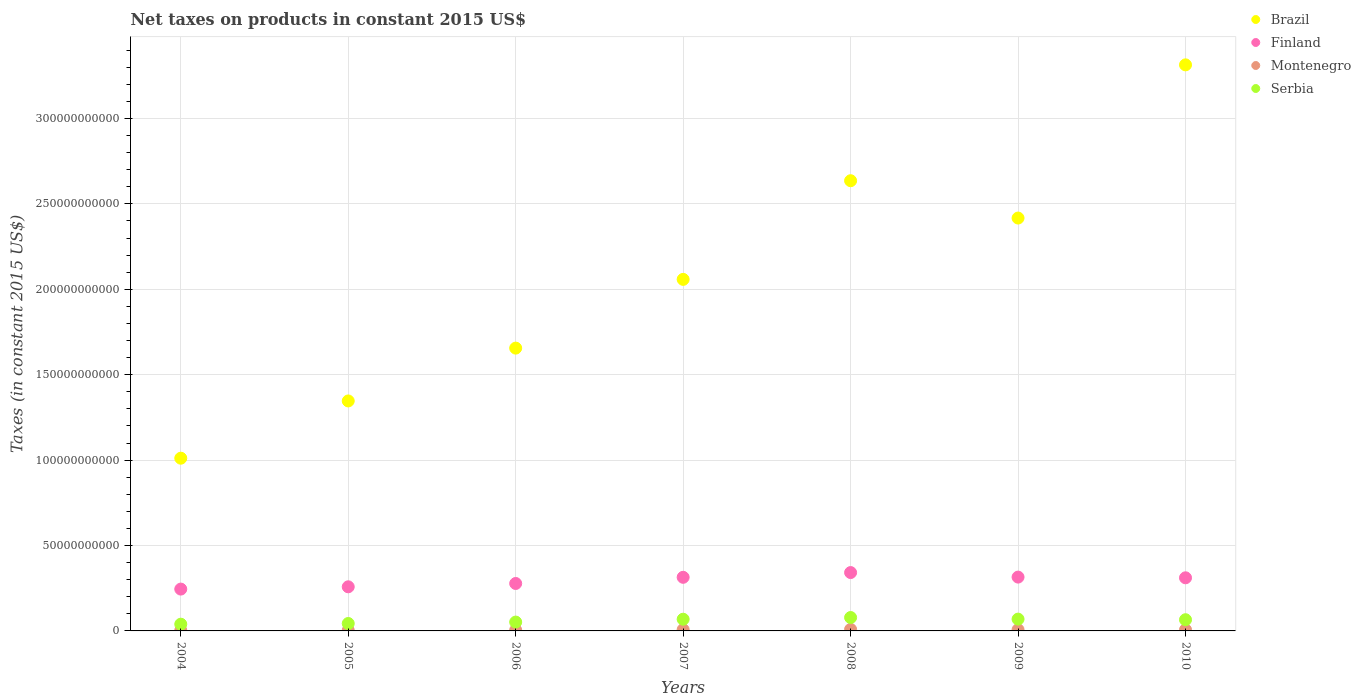What is the net taxes on products in Brazil in 2005?
Make the answer very short. 1.35e+11. Across all years, what is the maximum net taxes on products in Finland?
Your answer should be compact. 3.42e+1. Across all years, what is the minimum net taxes on products in Serbia?
Offer a terse response. 3.94e+09. In which year was the net taxes on products in Serbia maximum?
Provide a succinct answer. 2008. What is the total net taxes on products in Brazil in the graph?
Your answer should be compact. 1.44e+12. What is the difference between the net taxes on products in Serbia in 2004 and that in 2010?
Provide a short and direct response. -2.62e+09. What is the difference between the net taxes on products in Brazil in 2004 and the net taxes on products in Finland in 2008?
Offer a very short reply. 6.70e+1. What is the average net taxes on products in Serbia per year?
Your answer should be compact. 5.95e+09. In the year 2007, what is the difference between the net taxes on products in Serbia and net taxes on products in Montenegro?
Offer a very short reply. 6.09e+09. What is the ratio of the net taxes on products in Brazil in 2005 to that in 2007?
Give a very brief answer. 0.65. Is the difference between the net taxes on products in Serbia in 2005 and 2009 greater than the difference between the net taxes on products in Montenegro in 2005 and 2009?
Offer a very short reply. No. What is the difference between the highest and the second highest net taxes on products in Brazil?
Your answer should be very brief. 6.78e+1. What is the difference between the highest and the lowest net taxes on products in Brazil?
Your response must be concise. 2.30e+11. Is the sum of the net taxes on products in Montenegro in 2005 and 2010 greater than the maximum net taxes on products in Finland across all years?
Make the answer very short. No. Is it the case that in every year, the sum of the net taxes on products in Serbia and net taxes on products in Brazil  is greater than the sum of net taxes on products in Montenegro and net taxes on products in Finland?
Provide a short and direct response. Yes. Is it the case that in every year, the sum of the net taxes on products in Montenegro and net taxes on products in Brazil  is greater than the net taxes on products in Finland?
Give a very brief answer. Yes. Is the net taxes on products in Montenegro strictly greater than the net taxes on products in Brazil over the years?
Your answer should be compact. No. Are the values on the major ticks of Y-axis written in scientific E-notation?
Your answer should be compact. No. Does the graph contain any zero values?
Ensure brevity in your answer.  No. Does the graph contain grids?
Provide a succinct answer. Yes. Where does the legend appear in the graph?
Offer a very short reply. Top right. How are the legend labels stacked?
Your response must be concise. Vertical. What is the title of the graph?
Keep it short and to the point. Net taxes on products in constant 2015 US$. Does "Guatemala" appear as one of the legend labels in the graph?
Keep it short and to the point. No. What is the label or title of the Y-axis?
Keep it short and to the point. Taxes (in constant 2015 US$). What is the Taxes (in constant 2015 US$) of Brazil in 2004?
Your answer should be compact. 1.01e+11. What is the Taxes (in constant 2015 US$) in Finland in 2004?
Your answer should be very brief. 2.45e+1. What is the Taxes (in constant 2015 US$) in Montenegro in 2004?
Provide a short and direct response. 3.08e+08. What is the Taxes (in constant 2015 US$) in Serbia in 2004?
Give a very brief answer. 3.94e+09. What is the Taxes (in constant 2015 US$) of Brazil in 2005?
Offer a very short reply. 1.35e+11. What is the Taxes (in constant 2015 US$) in Finland in 2005?
Give a very brief answer. 2.58e+1. What is the Taxes (in constant 2015 US$) in Montenegro in 2005?
Make the answer very short. 3.67e+08. What is the Taxes (in constant 2015 US$) in Serbia in 2005?
Offer a very short reply. 4.35e+09. What is the Taxes (in constant 2015 US$) in Brazil in 2006?
Keep it short and to the point. 1.66e+11. What is the Taxes (in constant 2015 US$) in Finland in 2006?
Your answer should be very brief. 2.78e+1. What is the Taxes (in constant 2015 US$) in Montenegro in 2006?
Your answer should be compact. 4.97e+08. What is the Taxes (in constant 2015 US$) of Serbia in 2006?
Your answer should be very brief. 5.18e+09. What is the Taxes (in constant 2015 US$) of Brazil in 2007?
Provide a short and direct response. 2.06e+11. What is the Taxes (in constant 2015 US$) in Finland in 2007?
Keep it short and to the point. 3.14e+1. What is the Taxes (in constant 2015 US$) in Montenegro in 2007?
Make the answer very short. 7.52e+08. What is the Taxes (in constant 2015 US$) of Serbia in 2007?
Provide a succinct answer. 6.84e+09. What is the Taxes (in constant 2015 US$) in Brazil in 2008?
Offer a very short reply. 2.64e+11. What is the Taxes (in constant 2015 US$) of Finland in 2008?
Your answer should be compact. 3.42e+1. What is the Taxes (in constant 2015 US$) in Montenegro in 2008?
Keep it short and to the point. 8.92e+08. What is the Taxes (in constant 2015 US$) in Serbia in 2008?
Ensure brevity in your answer.  7.84e+09. What is the Taxes (in constant 2015 US$) of Brazil in 2009?
Keep it short and to the point. 2.42e+11. What is the Taxes (in constant 2015 US$) in Finland in 2009?
Make the answer very short. 3.15e+1. What is the Taxes (in constant 2015 US$) of Montenegro in 2009?
Provide a succinct answer. 7.06e+08. What is the Taxes (in constant 2015 US$) in Serbia in 2009?
Provide a succinct answer. 6.91e+09. What is the Taxes (in constant 2015 US$) of Brazil in 2010?
Offer a terse response. 3.31e+11. What is the Taxes (in constant 2015 US$) in Finland in 2010?
Offer a very short reply. 3.11e+1. What is the Taxes (in constant 2015 US$) of Montenegro in 2010?
Keep it short and to the point. 6.84e+08. What is the Taxes (in constant 2015 US$) in Serbia in 2010?
Make the answer very short. 6.56e+09. Across all years, what is the maximum Taxes (in constant 2015 US$) in Brazil?
Keep it short and to the point. 3.31e+11. Across all years, what is the maximum Taxes (in constant 2015 US$) of Finland?
Offer a very short reply. 3.42e+1. Across all years, what is the maximum Taxes (in constant 2015 US$) in Montenegro?
Ensure brevity in your answer.  8.92e+08. Across all years, what is the maximum Taxes (in constant 2015 US$) in Serbia?
Your answer should be very brief. 7.84e+09. Across all years, what is the minimum Taxes (in constant 2015 US$) of Brazil?
Ensure brevity in your answer.  1.01e+11. Across all years, what is the minimum Taxes (in constant 2015 US$) in Finland?
Give a very brief answer. 2.45e+1. Across all years, what is the minimum Taxes (in constant 2015 US$) in Montenegro?
Your response must be concise. 3.08e+08. Across all years, what is the minimum Taxes (in constant 2015 US$) of Serbia?
Your answer should be very brief. 3.94e+09. What is the total Taxes (in constant 2015 US$) of Brazil in the graph?
Offer a very short reply. 1.44e+12. What is the total Taxes (in constant 2015 US$) in Finland in the graph?
Offer a terse response. 2.06e+11. What is the total Taxes (in constant 2015 US$) of Montenegro in the graph?
Offer a terse response. 4.21e+09. What is the total Taxes (in constant 2015 US$) in Serbia in the graph?
Your answer should be compact. 4.16e+1. What is the difference between the Taxes (in constant 2015 US$) of Brazil in 2004 and that in 2005?
Offer a very short reply. -3.35e+1. What is the difference between the Taxes (in constant 2015 US$) in Finland in 2004 and that in 2005?
Ensure brevity in your answer.  -1.33e+09. What is the difference between the Taxes (in constant 2015 US$) of Montenegro in 2004 and that in 2005?
Provide a short and direct response. -5.85e+07. What is the difference between the Taxes (in constant 2015 US$) in Serbia in 2004 and that in 2005?
Your answer should be very brief. -4.05e+08. What is the difference between the Taxes (in constant 2015 US$) in Brazil in 2004 and that in 2006?
Your answer should be compact. -6.45e+1. What is the difference between the Taxes (in constant 2015 US$) of Finland in 2004 and that in 2006?
Provide a succinct answer. -3.28e+09. What is the difference between the Taxes (in constant 2015 US$) in Montenegro in 2004 and that in 2006?
Offer a very short reply. -1.89e+08. What is the difference between the Taxes (in constant 2015 US$) of Serbia in 2004 and that in 2006?
Your answer should be very brief. -1.24e+09. What is the difference between the Taxes (in constant 2015 US$) of Brazil in 2004 and that in 2007?
Your answer should be very brief. -1.05e+11. What is the difference between the Taxes (in constant 2015 US$) in Finland in 2004 and that in 2007?
Ensure brevity in your answer.  -6.89e+09. What is the difference between the Taxes (in constant 2015 US$) of Montenegro in 2004 and that in 2007?
Keep it short and to the point. -4.43e+08. What is the difference between the Taxes (in constant 2015 US$) of Serbia in 2004 and that in 2007?
Your answer should be compact. -2.90e+09. What is the difference between the Taxes (in constant 2015 US$) of Brazil in 2004 and that in 2008?
Ensure brevity in your answer.  -1.62e+11. What is the difference between the Taxes (in constant 2015 US$) of Finland in 2004 and that in 2008?
Give a very brief answer. -9.67e+09. What is the difference between the Taxes (in constant 2015 US$) of Montenegro in 2004 and that in 2008?
Make the answer very short. -5.84e+08. What is the difference between the Taxes (in constant 2015 US$) in Serbia in 2004 and that in 2008?
Offer a terse response. -3.90e+09. What is the difference between the Taxes (in constant 2015 US$) in Brazil in 2004 and that in 2009?
Keep it short and to the point. -1.41e+11. What is the difference between the Taxes (in constant 2015 US$) in Finland in 2004 and that in 2009?
Provide a succinct answer. -7.02e+09. What is the difference between the Taxes (in constant 2015 US$) of Montenegro in 2004 and that in 2009?
Provide a succinct answer. -3.98e+08. What is the difference between the Taxes (in constant 2015 US$) of Serbia in 2004 and that in 2009?
Give a very brief answer. -2.97e+09. What is the difference between the Taxes (in constant 2015 US$) in Brazil in 2004 and that in 2010?
Offer a terse response. -2.30e+11. What is the difference between the Taxes (in constant 2015 US$) of Finland in 2004 and that in 2010?
Make the answer very short. -6.61e+09. What is the difference between the Taxes (in constant 2015 US$) of Montenegro in 2004 and that in 2010?
Your answer should be compact. -3.76e+08. What is the difference between the Taxes (in constant 2015 US$) of Serbia in 2004 and that in 2010?
Keep it short and to the point. -2.62e+09. What is the difference between the Taxes (in constant 2015 US$) of Brazil in 2005 and that in 2006?
Offer a very short reply. -3.09e+1. What is the difference between the Taxes (in constant 2015 US$) of Finland in 2005 and that in 2006?
Make the answer very short. -1.95e+09. What is the difference between the Taxes (in constant 2015 US$) of Montenegro in 2005 and that in 2006?
Your answer should be compact. -1.30e+08. What is the difference between the Taxes (in constant 2015 US$) in Serbia in 2005 and that in 2006?
Make the answer very short. -8.37e+08. What is the difference between the Taxes (in constant 2015 US$) in Brazil in 2005 and that in 2007?
Your answer should be compact. -7.12e+1. What is the difference between the Taxes (in constant 2015 US$) in Finland in 2005 and that in 2007?
Your answer should be very brief. -5.56e+09. What is the difference between the Taxes (in constant 2015 US$) in Montenegro in 2005 and that in 2007?
Keep it short and to the point. -3.85e+08. What is the difference between the Taxes (in constant 2015 US$) of Serbia in 2005 and that in 2007?
Your response must be concise. -2.50e+09. What is the difference between the Taxes (in constant 2015 US$) in Brazil in 2005 and that in 2008?
Your response must be concise. -1.29e+11. What is the difference between the Taxes (in constant 2015 US$) in Finland in 2005 and that in 2008?
Make the answer very short. -8.34e+09. What is the difference between the Taxes (in constant 2015 US$) of Montenegro in 2005 and that in 2008?
Make the answer very short. -5.25e+08. What is the difference between the Taxes (in constant 2015 US$) of Serbia in 2005 and that in 2008?
Ensure brevity in your answer.  -3.50e+09. What is the difference between the Taxes (in constant 2015 US$) of Brazil in 2005 and that in 2009?
Your response must be concise. -1.07e+11. What is the difference between the Taxes (in constant 2015 US$) in Finland in 2005 and that in 2009?
Keep it short and to the point. -5.68e+09. What is the difference between the Taxes (in constant 2015 US$) in Montenegro in 2005 and that in 2009?
Ensure brevity in your answer.  -3.40e+08. What is the difference between the Taxes (in constant 2015 US$) in Serbia in 2005 and that in 2009?
Provide a short and direct response. -2.56e+09. What is the difference between the Taxes (in constant 2015 US$) of Brazil in 2005 and that in 2010?
Offer a terse response. -1.97e+11. What is the difference between the Taxes (in constant 2015 US$) of Finland in 2005 and that in 2010?
Ensure brevity in your answer.  -5.27e+09. What is the difference between the Taxes (in constant 2015 US$) of Montenegro in 2005 and that in 2010?
Provide a succinct answer. -3.17e+08. What is the difference between the Taxes (in constant 2015 US$) of Serbia in 2005 and that in 2010?
Your answer should be very brief. -2.21e+09. What is the difference between the Taxes (in constant 2015 US$) in Brazil in 2006 and that in 2007?
Ensure brevity in your answer.  -4.02e+1. What is the difference between the Taxes (in constant 2015 US$) in Finland in 2006 and that in 2007?
Provide a succinct answer. -3.61e+09. What is the difference between the Taxes (in constant 2015 US$) in Montenegro in 2006 and that in 2007?
Make the answer very short. -2.55e+08. What is the difference between the Taxes (in constant 2015 US$) in Serbia in 2006 and that in 2007?
Your response must be concise. -1.66e+09. What is the difference between the Taxes (in constant 2015 US$) in Brazil in 2006 and that in 2008?
Keep it short and to the point. -9.80e+1. What is the difference between the Taxes (in constant 2015 US$) in Finland in 2006 and that in 2008?
Provide a short and direct response. -6.39e+09. What is the difference between the Taxes (in constant 2015 US$) of Montenegro in 2006 and that in 2008?
Provide a succinct answer. -3.95e+08. What is the difference between the Taxes (in constant 2015 US$) of Serbia in 2006 and that in 2008?
Keep it short and to the point. -2.66e+09. What is the difference between the Taxes (in constant 2015 US$) of Brazil in 2006 and that in 2009?
Give a very brief answer. -7.61e+1. What is the difference between the Taxes (in constant 2015 US$) of Finland in 2006 and that in 2009?
Your response must be concise. -3.74e+09. What is the difference between the Taxes (in constant 2015 US$) in Montenegro in 2006 and that in 2009?
Your answer should be very brief. -2.09e+08. What is the difference between the Taxes (in constant 2015 US$) of Serbia in 2006 and that in 2009?
Keep it short and to the point. -1.73e+09. What is the difference between the Taxes (in constant 2015 US$) of Brazil in 2006 and that in 2010?
Ensure brevity in your answer.  -1.66e+11. What is the difference between the Taxes (in constant 2015 US$) in Finland in 2006 and that in 2010?
Offer a terse response. -3.32e+09. What is the difference between the Taxes (in constant 2015 US$) of Montenegro in 2006 and that in 2010?
Your response must be concise. -1.87e+08. What is the difference between the Taxes (in constant 2015 US$) of Serbia in 2006 and that in 2010?
Provide a short and direct response. -1.38e+09. What is the difference between the Taxes (in constant 2015 US$) in Brazil in 2007 and that in 2008?
Give a very brief answer. -5.78e+1. What is the difference between the Taxes (in constant 2015 US$) of Finland in 2007 and that in 2008?
Offer a very short reply. -2.78e+09. What is the difference between the Taxes (in constant 2015 US$) of Montenegro in 2007 and that in 2008?
Offer a very short reply. -1.40e+08. What is the difference between the Taxes (in constant 2015 US$) of Serbia in 2007 and that in 2008?
Your response must be concise. -9.99e+08. What is the difference between the Taxes (in constant 2015 US$) in Brazil in 2007 and that in 2009?
Keep it short and to the point. -3.59e+1. What is the difference between the Taxes (in constant 2015 US$) in Finland in 2007 and that in 2009?
Offer a terse response. -1.25e+08. What is the difference between the Taxes (in constant 2015 US$) in Montenegro in 2007 and that in 2009?
Your answer should be compact. 4.54e+07. What is the difference between the Taxes (in constant 2015 US$) in Serbia in 2007 and that in 2009?
Ensure brevity in your answer.  -6.60e+07. What is the difference between the Taxes (in constant 2015 US$) in Brazil in 2007 and that in 2010?
Provide a succinct answer. -1.26e+11. What is the difference between the Taxes (in constant 2015 US$) of Finland in 2007 and that in 2010?
Offer a very short reply. 2.86e+08. What is the difference between the Taxes (in constant 2015 US$) of Montenegro in 2007 and that in 2010?
Offer a terse response. 6.75e+07. What is the difference between the Taxes (in constant 2015 US$) in Serbia in 2007 and that in 2010?
Offer a terse response. 2.85e+08. What is the difference between the Taxes (in constant 2015 US$) of Brazil in 2008 and that in 2009?
Your response must be concise. 2.19e+1. What is the difference between the Taxes (in constant 2015 US$) of Finland in 2008 and that in 2009?
Offer a very short reply. 2.66e+09. What is the difference between the Taxes (in constant 2015 US$) in Montenegro in 2008 and that in 2009?
Your answer should be compact. 1.86e+08. What is the difference between the Taxes (in constant 2015 US$) in Serbia in 2008 and that in 2009?
Your answer should be very brief. 9.33e+08. What is the difference between the Taxes (in constant 2015 US$) of Brazil in 2008 and that in 2010?
Provide a succinct answer. -6.78e+1. What is the difference between the Taxes (in constant 2015 US$) of Finland in 2008 and that in 2010?
Your response must be concise. 3.07e+09. What is the difference between the Taxes (in constant 2015 US$) in Montenegro in 2008 and that in 2010?
Your response must be concise. 2.08e+08. What is the difference between the Taxes (in constant 2015 US$) of Serbia in 2008 and that in 2010?
Keep it short and to the point. 1.28e+09. What is the difference between the Taxes (in constant 2015 US$) in Brazil in 2009 and that in 2010?
Your answer should be very brief. -8.97e+1. What is the difference between the Taxes (in constant 2015 US$) of Finland in 2009 and that in 2010?
Your answer should be very brief. 4.11e+08. What is the difference between the Taxes (in constant 2015 US$) in Montenegro in 2009 and that in 2010?
Keep it short and to the point. 2.21e+07. What is the difference between the Taxes (in constant 2015 US$) of Serbia in 2009 and that in 2010?
Give a very brief answer. 3.51e+08. What is the difference between the Taxes (in constant 2015 US$) in Brazil in 2004 and the Taxes (in constant 2015 US$) in Finland in 2005?
Make the answer very short. 7.53e+1. What is the difference between the Taxes (in constant 2015 US$) in Brazil in 2004 and the Taxes (in constant 2015 US$) in Montenegro in 2005?
Keep it short and to the point. 1.01e+11. What is the difference between the Taxes (in constant 2015 US$) of Brazil in 2004 and the Taxes (in constant 2015 US$) of Serbia in 2005?
Give a very brief answer. 9.68e+1. What is the difference between the Taxes (in constant 2015 US$) in Finland in 2004 and the Taxes (in constant 2015 US$) in Montenegro in 2005?
Ensure brevity in your answer.  2.41e+1. What is the difference between the Taxes (in constant 2015 US$) of Finland in 2004 and the Taxes (in constant 2015 US$) of Serbia in 2005?
Offer a terse response. 2.01e+1. What is the difference between the Taxes (in constant 2015 US$) in Montenegro in 2004 and the Taxes (in constant 2015 US$) in Serbia in 2005?
Ensure brevity in your answer.  -4.04e+09. What is the difference between the Taxes (in constant 2015 US$) in Brazil in 2004 and the Taxes (in constant 2015 US$) in Finland in 2006?
Ensure brevity in your answer.  7.33e+1. What is the difference between the Taxes (in constant 2015 US$) of Brazil in 2004 and the Taxes (in constant 2015 US$) of Montenegro in 2006?
Your answer should be compact. 1.01e+11. What is the difference between the Taxes (in constant 2015 US$) of Brazil in 2004 and the Taxes (in constant 2015 US$) of Serbia in 2006?
Give a very brief answer. 9.59e+1. What is the difference between the Taxes (in constant 2015 US$) of Finland in 2004 and the Taxes (in constant 2015 US$) of Montenegro in 2006?
Your answer should be compact. 2.40e+1. What is the difference between the Taxes (in constant 2015 US$) of Finland in 2004 and the Taxes (in constant 2015 US$) of Serbia in 2006?
Keep it short and to the point. 1.93e+1. What is the difference between the Taxes (in constant 2015 US$) of Montenegro in 2004 and the Taxes (in constant 2015 US$) of Serbia in 2006?
Provide a succinct answer. -4.88e+09. What is the difference between the Taxes (in constant 2015 US$) in Brazil in 2004 and the Taxes (in constant 2015 US$) in Finland in 2007?
Make the answer very short. 6.97e+1. What is the difference between the Taxes (in constant 2015 US$) of Brazil in 2004 and the Taxes (in constant 2015 US$) of Montenegro in 2007?
Give a very brief answer. 1.00e+11. What is the difference between the Taxes (in constant 2015 US$) in Brazil in 2004 and the Taxes (in constant 2015 US$) in Serbia in 2007?
Ensure brevity in your answer.  9.43e+1. What is the difference between the Taxes (in constant 2015 US$) in Finland in 2004 and the Taxes (in constant 2015 US$) in Montenegro in 2007?
Make the answer very short. 2.37e+1. What is the difference between the Taxes (in constant 2015 US$) in Finland in 2004 and the Taxes (in constant 2015 US$) in Serbia in 2007?
Your answer should be compact. 1.76e+1. What is the difference between the Taxes (in constant 2015 US$) in Montenegro in 2004 and the Taxes (in constant 2015 US$) in Serbia in 2007?
Provide a succinct answer. -6.54e+09. What is the difference between the Taxes (in constant 2015 US$) of Brazil in 2004 and the Taxes (in constant 2015 US$) of Finland in 2008?
Give a very brief answer. 6.70e+1. What is the difference between the Taxes (in constant 2015 US$) of Brazil in 2004 and the Taxes (in constant 2015 US$) of Montenegro in 2008?
Your answer should be very brief. 1.00e+11. What is the difference between the Taxes (in constant 2015 US$) in Brazil in 2004 and the Taxes (in constant 2015 US$) in Serbia in 2008?
Your answer should be very brief. 9.33e+1. What is the difference between the Taxes (in constant 2015 US$) of Finland in 2004 and the Taxes (in constant 2015 US$) of Montenegro in 2008?
Provide a succinct answer. 2.36e+1. What is the difference between the Taxes (in constant 2015 US$) of Finland in 2004 and the Taxes (in constant 2015 US$) of Serbia in 2008?
Your response must be concise. 1.66e+1. What is the difference between the Taxes (in constant 2015 US$) of Montenegro in 2004 and the Taxes (in constant 2015 US$) of Serbia in 2008?
Your answer should be very brief. -7.54e+09. What is the difference between the Taxes (in constant 2015 US$) in Brazil in 2004 and the Taxes (in constant 2015 US$) in Finland in 2009?
Offer a terse response. 6.96e+1. What is the difference between the Taxes (in constant 2015 US$) of Brazil in 2004 and the Taxes (in constant 2015 US$) of Montenegro in 2009?
Give a very brief answer. 1.00e+11. What is the difference between the Taxes (in constant 2015 US$) in Brazil in 2004 and the Taxes (in constant 2015 US$) in Serbia in 2009?
Your answer should be very brief. 9.42e+1. What is the difference between the Taxes (in constant 2015 US$) of Finland in 2004 and the Taxes (in constant 2015 US$) of Montenegro in 2009?
Offer a terse response. 2.38e+1. What is the difference between the Taxes (in constant 2015 US$) of Finland in 2004 and the Taxes (in constant 2015 US$) of Serbia in 2009?
Make the answer very short. 1.76e+1. What is the difference between the Taxes (in constant 2015 US$) in Montenegro in 2004 and the Taxes (in constant 2015 US$) in Serbia in 2009?
Your answer should be very brief. -6.60e+09. What is the difference between the Taxes (in constant 2015 US$) of Brazil in 2004 and the Taxes (in constant 2015 US$) of Finland in 2010?
Offer a very short reply. 7.00e+1. What is the difference between the Taxes (in constant 2015 US$) of Brazil in 2004 and the Taxes (in constant 2015 US$) of Montenegro in 2010?
Ensure brevity in your answer.  1.00e+11. What is the difference between the Taxes (in constant 2015 US$) of Brazil in 2004 and the Taxes (in constant 2015 US$) of Serbia in 2010?
Provide a short and direct response. 9.46e+1. What is the difference between the Taxes (in constant 2015 US$) in Finland in 2004 and the Taxes (in constant 2015 US$) in Montenegro in 2010?
Keep it short and to the point. 2.38e+1. What is the difference between the Taxes (in constant 2015 US$) of Finland in 2004 and the Taxes (in constant 2015 US$) of Serbia in 2010?
Make the answer very short. 1.79e+1. What is the difference between the Taxes (in constant 2015 US$) of Montenegro in 2004 and the Taxes (in constant 2015 US$) of Serbia in 2010?
Your answer should be very brief. -6.25e+09. What is the difference between the Taxes (in constant 2015 US$) in Brazil in 2005 and the Taxes (in constant 2015 US$) in Finland in 2006?
Your answer should be very brief. 1.07e+11. What is the difference between the Taxes (in constant 2015 US$) of Brazil in 2005 and the Taxes (in constant 2015 US$) of Montenegro in 2006?
Your answer should be compact. 1.34e+11. What is the difference between the Taxes (in constant 2015 US$) of Brazil in 2005 and the Taxes (in constant 2015 US$) of Serbia in 2006?
Your response must be concise. 1.29e+11. What is the difference between the Taxes (in constant 2015 US$) of Finland in 2005 and the Taxes (in constant 2015 US$) of Montenegro in 2006?
Ensure brevity in your answer.  2.53e+1. What is the difference between the Taxes (in constant 2015 US$) in Finland in 2005 and the Taxes (in constant 2015 US$) in Serbia in 2006?
Your answer should be very brief. 2.06e+1. What is the difference between the Taxes (in constant 2015 US$) of Montenegro in 2005 and the Taxes (in constant 2015 US$) of Serbia in 2006?
Keep it short and to the point. -4.82e+09. What is the difference between the Taxes (in constant 2015 US$) of Brazil in 2005 and the Taxes (in constant 2015 US$) of Finland in 2007?
Make the answer very short. 1.03e+11. What is the difference between the Taxes (in constant 2015 US$) in Brazil in 2005 and the Taxes (in constant 2015 US$) in Montenegro in 2007?
Ensure brevity in your answer.  1.34e+11. What is the difference between the Taxes (in constant 2015 US$) of Brazil in 2005 and the Taxes (in constant 2015 US$) of Serbia in 2007?
Your answer should be compact. 1.28e+11. What is the difference between the Taxes (in constant 2015 US$) in Finland in 2005 and the Taxes (in constant 2015 US$) in Montenegro in 2007?
Your response must be concise. 2.51e+1. What is the difference between the Taxes (in constant 2015 US$) of Finland in 2005 and the Taxes (in constant 2015 US$) of Serbia in 2007?
Make the answer very short. 1.90e+1. What is the difference between the Taxes (in constant 2015 US$) of Montenegro in 2005 and the Taxes (in constant 2015 US$) of Serbia in 2007?
Provide a succinct answer. -6.48e+09. What is the difference between the Taxes (in constant 2015 US$) of Brazil in 2005 and the Taxes (in constant 2015 US$) of Finland in 2008?
Your response must be concise. 1.00e+11. What is the difference between the Taxes (in constant 2015 US$) of Brazil in 2005 and the Taxes (in constant 2015 US$) of Montenegro in 2008?
Ensure brevity in your answer.  1.34e+11. What is the difference between the Taxes (in constant 2015 US$) in Brazil in 2005 and the Taxes (in constant 2015 US$) in Serbia in 2008?
Make the answer very short. 1.27e+11. What is the difference between the Taxes (in constant 2015 US$) in Finland in 2005 and the Taxes (in constant 2015 US$) in Montenegro in 2008?
Provide a short and direct response. 2.49e+1. What is the difference between the Taxes (in constant 2015 US$) of Finland in 2005 and the Taxes (in constant 2015 US$) of Serbia in 2008?
Keep it short and to the point. 1.80e+1. What is the difference between the Taxes (in constant 2015 US$) of Montenegro in 2005 and the Taxes (in constant 2015 US$) of Serbia in 2008?
Provide a short and direct response. -7.48e+09. What is the difference between the Taxes (in constant 2015 US$) of Brazil in 2005 and the Taxes (in constant 2015 US$) of Finland in 2009?
Make the answer very short. 1.03e+11. What is the difference between the Taxes (in constant 2015 US$) in Brazil in 2005 and the Taxes (in constant 2015 US$) in Montenegro in 2009?
Provide a short and direct response. 1.34e+11. What is the difference between the Taxes (in constant 2015 US$) in Brazil in 2005 and the Taxes (in constant 2015 US$) in Serbia in 2009?
Ensure brevity in your answer.  1.28e+11. What is the difference between the Taxes (in constant 2015 US$) in Finland in 2005 and the Taxes (in constant 2015 US$) in Montenegro in 2009?
Your answer should be compact. 2.51e+1. What is the difference between the Taxes (in constant 2015 US$) in Finland in 2005 and the Taxes (in constant 2015 US$) in Serbia in 2009?
Your response must be concise. 1.89e+1. What is the difference between the Taxes (in constant 2015 US$) in Montenegro in 2005 and the Taxes (in constant 2015 US$) in Serbia in 2009?
Offer a terse response. -6.54e+09. What is the difference between the Taxes (in constant 2015 US$) of Brazil in 2005 and the Taxes (in constant 2015 US$) of Finland in 2010?
Provide a succinct answer. 1.04e+11. What is the difference between the Taxes (in constant 2015 US$) in Brazil in 2005 and the Taxes (in constant 2015 US$) in Montenegro in 2010?
Make the answer very short. 1.34e+11. What is the difference between the Taxes (in constant 2015 US$) of Brazil in 2005 and the Taxes (in constant 2015 US$) of Serbia in 2010?
Provide a short and direct response. 1.28e+11. What is the difference between the Taxes (in constant 2015 US$) in Finland in 2005 and the Taxes (in constant 2015 US$) in Montenegro in 2010?
Your response must be concise. 2.51e+1. What is the difference between the Taxes (in constant 2015 US$) in Finland in 2005 and the Taxes (in constant 2015 US$) in Serbia in 2010?
Offer a very short reply. 1.93e+1. What is the difference between the Taxes (in constant 2015 US$) of Montenegro in 2005 and the Taxes (in constant 2015 US$) of Serbia in 2010?
Your response must be concise. -6.19e+09. What is the difference between the Taxes (in constant 2015 US$) in Brazil in 2006 and the Taxes (in constant 2015 US$) in Finland in 2007?
Your answer should be compact. 1.34e+11. What is the difference between the Taxes (in constant 2015 US$) of Brazil in 2006 and the Taxes (in constant 2015 US$) of Montenegro in 2007?
Give a very brief answer. 1.65e+11. What is the difference between the Taxes (in constant 2015 US$) of Brazil in 2006 and the Taxes (in constant 2015 US$) of Serbia in 2007?
Give a very brief answer. 1.59e+11. What is the difference between the Taxes (in constant 2015 US$) of Finland in 2006 and the Taxes (in constant 2015 US$) of Montenegro in 2007?
Ensure brevity in your answer.  2.70e+1. What is the difference between the Taxes (in constant 2015 US$) in Finland in 2006 and the Taxes (in constant 2015 US$) in Serbia in 2007?
Keep it short and to the point. 2.09e+1. What is the difference between the Taxes (in constant 2015 US$) of Montenegro in 2006 and the Taxes (in constant 2015 US$) of Serbia in 2007?
Ensure brevity in your answer.  -6.35e+09. What is the difference between the Taxes (in constant 2015 US$) in Brazil in 2006 and the Taxes (in constant 2015 US$) in Finland in 2008?
Your answer should be very brief. 1.31e+11. What is the difference between the Taxes (in constant 2015 US$) of Brazil in 2006 and the Taxes (in constant 2015 US$) of Montenegro in 2008?
Keep it short and to the point. 1.65e+11. What is the difference between the Taxes (in constant 2015 US$) in Brazil in 2006 and the Taxes (in constant 2015 US$) in Serbia in 2008?
Provide a succinct answer. 1.58e+11. What is the difference between the Taxes (in constant 2015 US$) of Finland in 2006 and the Taxes (in constant 2015 US$) of Montenegro in 2008?
Your answer should be very brief. 2.69e+1. What is the difference between the Taxes (in constant 2015 US$) in Finland in 2006 and the Taxes (in constant 2015 US$) in Serbia in 2008?
Your response must be concise. 1.99e+1. What is the difference between the Taxes (in constant 2015 US$) in Montenegro in 2006 and the Taxes (in constant 2015 US$) in Serbia in 2008?
Keep it short and to the point. -7.35e+09. What is the difference between the Taxes (in constant 2015 US$) in Brazil in 2006 and the Taxes (in constant 2015 US$) in Finland in 2009?
Your answer should be compact. 1.34e+11. What is the difference between the Taxes (in constant 2015 US$) in Brazil in 2006 and the Taxes (in constant 2015 US$) in Montenegro in 2009?
Offer a very short reply. 1.65e+11. What is the difference between the Taxes (in constant 2015 US$) of Brazil in 2006 and the Taxes (in constant 2015 US$) of Serbia in 2009?
Provide a succinct answer. 1.59e+11. What is the difference between the Taxes (in constant 2015 US$) in Finland in 2006 and the Taxes (in constant 2015 US$) in Montenegro in 2009?
Give a very brief answer. 2.71e+1. What is the difference between the Taxes (in constant 2015 US$) in Finland in 2006 and the Taxes (in constant 2015 US$) in Serbia in 2009?
Your answer should be compact. 2.09e+1. What is the difference between the Taxes (in constant 2015 US$) of Montenegro in 2006 and the Taxes (in constant 2015 US$) of Serbia in 2009?
Provide a succinct answer. -6.41e+09. What is the difference between the Taxes (in constant 2015 US$) in Brazil in 2006 and the Taxes (in constant 2015 US$) in Finland in 2010?
Provide a short and direct response. 1.34e+11. What is the difference between the Taxes (in constant 2015 US$) of Brazil in 2006 and the Taxes (in constant 2015 US$) of Montenegro in 2010?
Your answer should be very brief. 1.65e+11. What is the difference between the Taxes (in constant 2015 US$) of Brazil in 2006 and the Taxes (in constant 2015 US$) of Serbia in 2010?
Make the answer very short. 1.59e+11. What is the difference between the Taxes (in constant 2015 US$) in Finland in 2006 and the Taxes (in constant 2015 US$) in Montenegro in 2010?
Provide a succinct answer. 2.71e+1. What is the difference between the Taxes (in constant 2015 US$) of Finland in 2006 and the Taxes (in constant 2015 US$) of Serbia in 2010?
Your response must be concise. 2.12e+1. What is the difference between the Taxes (in constant 2015 US$) of Montenegro in 2006 and the Taxes (in constant 2015 US$) of Serbia in 2010?
Ensure brevity in your answer.  -6.06e+09. What is the difference between the Taxes (in constant 2015 US$) of Brazil in 2007 and the Taxes (in constant 2015 US$) of Finland in 2008?
Provide a succinct answer. 1.72e+11. What is the difference between the Taxes (in constant 2015 US$) in Brazil in 2007 and the Taxes (in constant 2015 US$) in Montenegro in 2008?
Give a very brief answer. 2.05e+11. What is the difference between the Taxes (in constant 2015 US$) in Brazil in 2007 and the Taxes (in constant 2015 US$) in Serbia in 2008?
Keep it short and to the point. 1.98e+11. What is the difference between the Taxes (in constant 2015 US$) of Finland in 2007 and the Taxes (in constant 2015 US$) of Montenegro in 2008?
Your response must be concise. 3.05e+1. What is the difference between the Taxes (in constant 2015 US$) in Finland in 2007 and the Taxes (in constant 2015 US$) in Serbia in 2008?
Make the answer very short. 2.35e+1. What is the difference between the Taxes (in constant 2015 US$) in Montenegro in 2007 and the Taxes (in constant 2015 US$) in Serbia in 2008?
Keep it short and to the point. -7.09e+09. What is the difference between the Taxes (in constant 2015 US$) in Brazil in 2007 and the Taxes (in constant 2015 US$) in Finland in 2009?
Ensure brevity in your answer.  1.74e+11. What is the difference between the Taxes (in constant 2015 US$) of Brazil in 2007 and the Taxes (in constant 2015 US$) of Montenegro in 2009?
Your answer should be very brief. 2.05e+11. What is the difference between the Taxes (in constant 2015 US$) in Brazil in 2007 and the Taxes (in constant 2015 US$) in Serbia in 2009?
Ensure brevity in your answer.  1.99e+11. What is the difference between the Taxes (in constant 2015 US$) in Finland in 2007 and the Taxes (in constant 2015 US$) in Montenegro in 2009?
Your answer should be very brief. 3.07e+1. What is the difference between the Taxes (in constant 2015 US$) in Finland in 2007 and the Taxes (in constant 2015 US$) in Serbia in 2009?
Provide a short and direct response. 2.45e+1. What is the difference between the Taxes (in constant 2015 US$) of Montenegro in 2007 and the Taxes (in constant 2015 US$) of Serbia in 2009?
Your answer should be very brief. -6.16e+09. What is the difference between the Taxes (in constant 2015 US$) of Brazil in 2007 and the Taxes (in constant 2015 US$) of Finland in 2010?
Your answer should be compact. 1.75e+11. What is the difference between the Taxes (in constant 2015 US$) of Brazil in 2007 and the Taxes (in constant 2015 US$) of Montenegro in 2010?
Your answer should be very brief. 2.05e+11. What is the difference between the Taxes (in constant 2015 US$) in Brazil in 2007 and the Taxes (in constant 2015 US$) in Serbia in 2010?
Offer a terse response. 1.99e+11. What is the difference between the Taxes (in constant 2015 US$) in Finland in 2007 and the Taxes (in constant 2015 US$) in Montenegro in 2010?
Keep it short and to the point. 3.07e+1. What is the difference between the Taxes (in constant 2015 US$) of Finland in 2007 and the Taxes (in constant 2015 US$) of Serbia in 2010?
Provide a short and direct response. 2.48e+1. What is the difference between the Taxes (in constant 2015 US$) of Montenegro in 2007 and the Taxes (in constant 2015 US$) of Serbia in 2010?
Provide a succinct answer. -5.81e+09. What is the difference between the Taxes (in constant 2015 US$) in Brazil in 2008 and the Taxes (in constant 2015 US$) in Finland in 2009?
Offer a terse response. 2.32e+11. What is the difference between the Taxes (in constant 2015 US$) of Brazil in 2008 and the Taxes (in constant 2015 US$) of Montenegro in 2009?
Provide a short and direct response. 2.63e+11. What is the difference between the Taxes (in constant 2015 US$) of Brazil in 2008 and the Taxes (in constant 2015 US$) of Serbia in 2009?
Your response must be concise. 2.57e+11. What is the difference between the Taxes (in constant 2015 US$) in Finland in 2008 and the Taxes (in constant 2015 US$) in Montenegro in 2009?
Provide a succinct answer. 3.35e+1. What is the difference between the Taxes (in constant 2015 US$) of Finland in 2008 and the Taxes (in constant 2015 US$) of Serbia in 2009?
Offer a terse response. 2.73e+1. What is the difference between the Taxes (in constant 2015 US$) in Montenegro in 2008 and the Taxes (in constant 2015 US$) in Serbia in 2009?
Make the answer very short. -6.02e+09. What is the difference between the Taxes (in constant 2015 US$) in Brazil in 2008 and the Taxes (in constant 2015 US$) in Finland in 2010?
Offer a very short reply. 2.32e+11. What is the difference between the Taxes (in constant 2015 US$) in Brazil in 2008 and the Taxes (in constant 2015 US$) in Montenegro in 2010?
Make the answer very short. 2.63e+11. What is the difference between the Taxes (in constant 2015 US$) of Brazil in 2008 and the Taxes (in constant 2015 US$) of Serbia in 2010?
Provide a succinct answer. 2.57e+11. What is the difference between the Taxes (in constant 2015 US$) in Finland in 2008 and the Taxes (in constant 2015 US$) in Montenegro in 2010?
Keep it short and to the point. 3.35e+1. What is the difference between the Taxes (in constant 2015 US$) in Finland in 2008 and the Taxes (in constant 2015 US$) in Serbia in 2010?
Your answer should be compact. 2.76e+1. What is the difference between the Taxes (in constant 2015 US$) in Montenegro in 2008 and the Taxes (in constant 2015 US$) in Serbia in 2010?
Give a very brief answer. -5.67e+09. What is the difference between the Taxes (in constant 2015 US$) of Brazil in 2009 and the Taxes (in constant 2015 US$) of Finland in 2010?
Offer a terse response. 2.11e+11. What is the difference between the Taxes (in constant 2015 US$) in Brazil in 2009 and the Taxes (in constant 2015 US$) in Montenegro in 2010?
Provide a short and direct response. 2.41e+11. What is the difference between the Taxes (in constant 2015 US$) of Brazil in 2009 and the Taxes (in constant 2015 US$) of Serbia in 2010?
Give a very brief answer. 2.35e+11. What is the difference between the Taxes (in constant 2015 US$) in Finland in 2009 and the Taxes (in constant 2015 US$) in Montenegro in 2010?
Ensure brevity in your answer.  3.08e+1. What is the difference between the Taxes (in constant 2015 US$) in Finland in 2009 and the Taxes (in constant 2015 US$) in Serbia in 2010?
Provide a short and direct response. 2.50e+1. What is the difference between the Taxes (in constant 2015 US$) of Montenegro in 2009 and the Taxes (in constant 2015 US$) of Serbia in 2010?
Give a very brief answer. -5.85e+09. What is the average Taxes (in constant 2015 US$) in Brazil per year?
Your response must be concise. 2.06e+11. What is the average Taxes (in constant 2015 US$) in Finland per year?
Keep it short and to the point. 2.95e+1. What is the average Taxes (in constant 2015 US$) of Montenegro per year?
Ensure brevity in your answer.  6.01e+08. What is the average Taxes (in constant 2015 US$) of Serbia per year?
Offer a very short reply. 5.95e+09. In the year 2004, what is the difference between the Taxes (in constant 2015 US$) in Brazil and Taxes (in constant 2015 US$) in Finland?
Offer a terse response. 7.66e+1. In the year 2004, what is the difference between the Taxes (in constant 2015 US$) of Brazil and Taxes (in constant 2015 US$) of Montenegro?
Offer a very short reply. 1.01e+11. In the year 2004, what is the difference between the Taxes (in constant 2015 US$) in Brazil and Taxes (in constant 2015 US$) in Serbia?
Ensure brevity in your answer.  9.72e+1. In the year 2004, what is the difference between the Taxes (in constant 2015 US$) of Finland and Taxes (in constant 2015 US$) of Montenegro?
Keep it short and to the point. 2.42e+1. In the year 2004, what is the difference between the Taxes (in constant 2015 US$) in Finland and Taxes (in constant 2015 US$) in Serbia?
Offer a terse response. 2.05e+1. In the year 2004, what is the difference between the Taxes (in constant 2015 US$) of Montenegro and Taxes (in constant 2015 US$) of Serbia?
Offer a terse response. -3.63e+09. In the year 2005, what is the difference between the Taxes (in constant 2015 US$) of Brazil and Taxes (in constant 2015 US$) of Finland?
Your answer should be compact. 1.09e+11. In the year 2005, what is the difference between the Taxes (in constant 2015 US$) of Brazil and Taxes (in constant 2015 US$) of Montenegro?
Provide a short and direct response. 1.34e+11. In the year 2005, what is the difference between the Taxes (in constant 2015 US$) in Brazil and Taxes (in constant 2015 US$) in Serbia?
Provide a short and direct response. 1.30e+11. In the year 2005, what is the difference between the Taxes (in constant 2015 US$) of Finland and Taxes (in constant 2015 US$) of Montenegro?
Your response must be concise. 2.55e+1. In the year 2005, what is the difference between the Taxes (in constant 2015 US$) in Finland and Taxes (in constant 2015 US$) in Serbia?
Offer a terse response. 2.15e+1. In the year 2005, what is the difference between the Taxes (in constant 2015 US$) in Montenegro and Taxes (in constant 2015 US$) in Serbia?
Your answer should be compact. -3.98e+09. In the year 2006, what is the difference between the Taxes (in constant 2015 US$) of Brazil and Taxes (in constant 2015 US$) of Finland?
Your response must be concise. 1.38e+11. In the year 2006, what is the difference between the Taxes (in constant 2015 US$) of Brazil and Taxes (in constant 2015 US$) of Montenegro?
Offer a very short reply. 1.65e+11. In the year 2006, what is the difference between the Taxes (in constant 2015 US$) in Brazil and Taxes (in constant 2015 US$) in Serbia?
Offer a terse response. 1.60e+11. In the year 2006, what is the difference between the Taxes (in constant 2015 US$) of Finland and Taxes (in constant 2015 US$) of Montenegro?
Offer a terse response. 2.73e+1. In the year 2006, what is the difference between the Taxes (in constant 2015 US$) of Finland and Taxes (in constant 2015 US$) of Serbia?
Your response must be concise. 2.26e+1. In the year 2006, what is the difference between the Taxes (in constant 2015 US$) of Montenegro and Taxes (in constant 2015 US$) of Serbia?
Ensure brevity in your answer.  -4.69e+09. In the year 2007, what is the difference between the Taxes (in constant 2015 US$) of Brazil and Taxes (in constant 2015 US$) of Finland?
Provide a succinct answer. 1.74e+11. In the year 2007, what is the difference between the Taxes (in constant 2015 US$) of Brazil and Taxes (in constant 2015 US$) of Montenegro?
Your answer should be very brief. 2.05e+11. In the year 2007, what is the difference between the Taxes (in constant 2015 US$) of Brazil and Taxes (in constant 2015 US$) of Serbia?
Make the answer very short. 1.99e+11. In the year 2007, what is the difference between the Taxes (in constant 2015 US$) in Finland and Taxes (in constant 2015 US$) in Montenegro?
Keep it short and to the point. 3.06e+1. In the year 2007, what is the difference between the Taxes (in constant 2015 US$) of Finland and Taxes (in constant 2015 US$) of Serbia?
Ensure brevity in your answer.  2.45e+1. In the year 2007, what is the difference between the Taxes (in constant 2015 US$) of Montenegro and Taxes (in constant 2015 US$) of Serbia?
Provide a succinct answer. -6.09e+09. In the year 2008, what is the difference between the Taxes (in constant 2015 US$) of Brazil and Taxes (in constant 2015 US$) of Finland?
Keep it short and to the point. 2.29e+11. In the year 2008, what is the difference between the Taxes (in constant 2015 US$) in Brazil and Taxes (in constant 2015 US$) in Montenegro?
Offer a terse response. 2.63e+11. In the year 2008, what is the difference between the Taxes (in constant 2015 US$) of Brazil and Taxes (in constant 2015 US$) of Serbia?
Make the answer very short. 2.56e+11. In the year 2008, what is the difference between the Taxes (in constant 2015 US$) in Finland and Taxes (in constant 2015 US$) in Montenegro?
Your response must be concise. 3.33e+1. In the year 2008, what is the difference between the Taxes (in constant 2015 US$) in Finland and Taxes (in constant 2015 US$) in Serbia?
Give a very brief answer. 2.63e+1. In the year 2008, what is the difference between the Taxes (in constant 2015 US$) of Montenegro and Taxes (in constant 2015 US$) of Serbia?
Your answer should be compact. -6.95e+09. In the year 2009, what is the difference between the Taxes (in constant 2015 US$) in Brazil and Taxes (in constant 2015 US$) in Finland?
Keep it short and to the point. 2.10e+11. In the year 2009, what is the difference between the Taxes (in constant 2015 US$) of Brazil and Taxes (in constant 2015 US$) of Montenegro?
Ensure brevity in your answer.  2.41e+11. In the year 2009, what is the difference between the Taxes (in constant 2015 US$) of Brazil and Taxes (in constant 2015 US$) of Serbia?
Provide a short and direct response. 2.35e+11. In the year 2009, what is the difference between the Taxes (in constant 2015 US$) of Finland and Taxes (in constant 2015 US$) of Montenegro?
Give a very brief answer. 3.08e+1. In the year 2009, what is the difference between the Taxes (in constant 2015 US$) of Finland and Taxes (in constant 2015 US$) of Serbia?
Offer a terse response. 2.46e+1. In the year 2009, what is the difference between the Taxes (in constant 2015 US$) of Montenegro and Taxes (in constant 2015 US$) of Serbia?
Offer a very short reply. -6.20e+09. In the year 2010, what is the difference between the Taxes (in constant 2015 US$) of Brazil and Taxes (in constant 2015 US$) of Finland?
Give a very brief answer. 3.00e+11. In the year 2010, what is the difference between the Taxes (in constant 2015 US$) in Brazil and Taxes (in constant 2015 US$) in Montenegro?
Provide a succinct answer. 3.31e+11. In the year 2010, what is the difference between the Taxes (in constant 2015 US$) of Brazil and Taxes (in constant 2015 US$) of Serbia?
Your response must be concise. 3.25e+11. In the year 2010, what is the difference between the Taxes (in constant 2015 US$) in Finland and Taxes (in constant 2015 US$) in Montenegro?
Your answer should be compact. 3.04e+1. In the year 2010, what is the difference between the Taxes (in constant 2015 US$) of Finland and Taxes (in constant 2015 US$) of Serbia?
Your response must be concise. 2.45e+1. In the year 2010, what is the difference between the Taxes (in constant 2015 US$) of Montenegro and Taxes (in constant 2015 US$) of Serbia?
Ensure brevity in your answer.  -5.88e+09. What is the ratio of the Taxes (in constant 2015 US$) of Brazil in 2004 to that in 2005?
Offer a terse response. 0.75. What is the ratio of the Taxes (in constant 2015 US$) of Finland in 2004 to that in 2005?
Offer a very short reply. 0.95. What is the ratio of the Taxes (in constant 2015 US$) of Montenegro in 2004 to that in 2005?
Your response must be concise. 0.84. What is the ratio of the Taxes (in constant 2015 US$) of Serbia in 2004 to that in 2005?
Ensure brevity in your answer.  0.91. What is the ratio of the Taxes (in constant 2015 US$) of Brazil in 2004 to that in 2006?
Your answer should be very brief. 0.61. What is the ratio of the Taxes (in constant 2015 US$) in Finland in 2004 to that in 2006?
Make the answer very short. 0.88. What is the ratio of the Taxes (in constant 2015 US$) in Montenegro in 2004 to that in 2006?
Offer a terse response. 0.62. What is the ratio of the Taxes (in constant 2015 US$) in Serbia in 2004 to that in 2006?
Provide a short and direct response. 0.76. What is the ratio of the Taxes (in constant 2015 US$) in Brazil in 2004 to that in 2007?
Offer a terse response. 0.49. What is the ratio of the Taxes (in constant 2015 US$) of Finland in 2004 to that in 2007?
Give a very brief answer. 0.78. What is the ratio of the Taxes (in constant 2015 US$) in Montenegro in 2004 to that in 2007?
Your answer should be very brief. 0.41. What is the ratio of the Taxes (in constant 2015 US$) in Serbia in 2004 to that in 2007?
Your answer should be very brief. 0.58. What is the ratio of the Taxes (in constant 2015 US$) of Brazil in 2004 to that in 2008?
Offer a terse response. 0.38. What is the ratio of the Taxes (in constant 2015 US$) in Finland in 2004 to that in 2008?
Provide a short and direct response. 0.72. What is the ratio of the Taxes (in constant 2015 US$) in Montenegro in 2004 to that in 2008?
Provide a short and direct response. 0.35. What is the ratio of the Taxes (in constant 2015 US$) of Serbia in 2004 to that in 2008?
Provide a short and direct response. 0.5. What is the ratio of the Taxes (in constant 2015 US$) of Brazil in 2004 to that in 2009?
Make the answer very short. 0.42. What is the ratio of the Taxes (in constant 2015 US$) in Finland in 2004 to that in 2009?
Give a very brief answer. 0.78. What is the ratio of the Taxes (in constant 2015 US$) in Montenegro in 2004 to that in 2009?
Offer a very short reply. 0.44. What is the ratio of the Taxes (in constant 2015 US$) in Serbia in 2004 to that in 2009?
Provide a succinct answer. 0.57. What is the ratio of the Taxes (in constant 2015 US$) in Brazil in 2004 to that in 2010?
Make the answer very short. 0.31. What is the ratio of the Taxes (in constant 2015 US$) in Finland in 2004 to that in 2010?
Ensure brevity in your answer.  0.79. What is the ratio of the Taxes (in constant 2015 US$) in Montenegro in 2004 to that in 2010?
Your response must be concise. 0.45. What is the ratio of the Taxes (in constant 2015 US$) in Serbia in 2004 to that in 2010?
Give a very brief answer. 0.6. What is the ratio of the Taxes (in constant 2015 US$) of Brazil in 2005 to that in 2006?
Provide a succinct answer. 0.81. What is the ratio of the Taxes (in constant 2015 US$) of Finland in 2005 to that in 2006?
Your response must be concise. 0.93. What is the ratio of the Taxes (in constant 2015 US$) in Montenegro in 2005 to that in 2006?
Your response must be concise. 0.74. What is the ratio of the Taxes (in constant 2015 US$) in Serbia in 2005 to that in 2006?
Provide a short and direct response. 0.84. What is the ratio of the Taxes (in constant 2015 US$) in Brazil in 2005 to that in 2007?
Your answer should be very brief. 0.65. What is the ratio of the Taxes (in constant 2015 US$) in Finland in 2005 to that in 2007?
Give a very brief answer. 0.82. What is the ratio of the Taxes (in constant 2015 US$) in Montenegro in 2005 to that in 2007?
Your answer should be very brief. 0.49. What is the ratio of the Taxes (in constant 2015 US$) in Serbia in 2005 to that in 2007?
Your answer should be compact. 0.64. What is the ratio of the Taxes (in constant 2015 US$) in Brazil in 2005 to that in 2008?
Give a very brief answer. 0.51. What is the ratio of the Taxes (in constant 2015 US$) in Finland in 2005 to that in 2008?
Provide a short and direct response. 0.76. What is the ratio of the Taxes (in constant 2015 US$) in Montenegro in 2005 to that in 2008?
Provide a short and direct response. 0.41. What is the ratio of the Taxes (in constant 2015 US$) in Serbia in 2005 to that in 2008?
Your answer should be very brief. 0.55. What is the ratio of the Taxes (in constant 2015 US$) in Brazil in 2005 to that in 2009?
Your response must be concise. 0.56. What is the ratio of the Taxes (in constant 2015 US$) of Finland in 2005 to that in 2009?
Make the answer very short. 0.82. What is the ratio of the Taxes (in constant 2015 US$) in Montenegro in 2005 to that in 2009?
Your response must be concise. 0.52. What is the ratio of the Taxes (in constant 2015 US$) of Serbia in 2005 to that in 2009?
Your answer should be very brief. 0.63. What is the ratio of the Taxes (in constant 2015 US$) in Brazil in 2005 to that in 2010?
Your response must be concise. 0.41. What is the ratio of the Taxes (in constant 2015 US$) of Finland in 2005 to that in 2010?
Keep it short and to the point. 0.83. What is the ratio of the Taxes (in constant 2015 US$) in Montenegro in 2005 to that in 2010?
Offer a terse response. 0.54. What is the ratio of the Taxes (in constant 2015 US$) in Serbia in 2005 to that in 2010?
Make the answer very short. 0.66. What is the ratio of the Taxes (in constant 2015 US$) in Brazil in 2006 to that in 2007?
Your answer should be compact. 0.8. What is the ratio of the Taxes (in constant 2015 US$) in Finland in 2006 to that in 2007?
Your response must be concise. 0.89. What is the ratio of the Taxes (in constant 2015 US$) of Montenegro in 2006 to that in 2007?
Offer a terse response. 0.66. What is the ratio of the Taxes (in constant 2015 US$) in Serbia in 2006 to that in 2007?
Give a very brief answer. 0.76. What is the ratio of the Taxes (in constant 2015 US$) of Brazil in 2006 to that in 2008?
Offer a very short reply. 0.63. What is the ratio of the Taxes (in constant 2015 US$) in Finland in 2006 to that in 2008?
Offer a terse response. 0.81. What is the ratio of the Taxes (in constant 2015 US$) in Montenegro in 2006 to that in 2008?
Make the answer very short. 0.56. What is the ratio of the Taxes (in constant 2015 US$) in Serbia in 2006 to that in 2008?
Make the answer very short. 0.66. What is the ratio of the Taxes (in constant 2015 US$) in Brazil in 2006 to that in 2009?
Make the answer very short. 0.69. What is the ratio of the Taxes (in constant 2015 US$) of Finland in 2006 to that in 2009?
Ensure brevity in your answer.  0.88. What is the ratio of the Taxes (in constant 2015 US$) of Montenegro in 2006 to that in 2009?
Your response must be concise. 0.7. What is the ratio of the Taxes (in constant 2015 US$) of Serbia in 2006 to that in 2009?
Give a very brief answer. 0.75. What is the ratio of the Taxes (in constant 2015 US$) of Brazil in 2006 to that in 2010?
Your response must be concise. 0.5. What is the ratio of the Taxes (in constant 2015 US$) in Finland in 2006 to that in 2010?
Ensure brevity in your answer.  0.89. What is the ratio of the Taxes (in constant 2015 US$) of Montenegro in 2006 to that in 2010?
Offer a very short reply. 0.73. What is the ratio of the Taxes (in constant 2015 US$) of Serbia in 2006 to that in 2010?
Ensure brevity in your answer.  0.79. What is the ratio of the Taxes (in constant 2015 US$) of Brazil in 2007 to that in 2008?
Ensure brevity in your answer.  0.78. What is the ratio of the Taxes (in constant 2015 US$) of Finland in 2007 to that in 2008?
Provide a short and direct response. 0.92. What is the ratio of the Taxes (in constant 2015 US$) of Montenegro in 2007 to that in 2008?
Ensure brevity in your answer.  0.84. What is the ratio of the Taxes (in constant 2015 US$) of Serbia in 2007 to that in 2008?
Offer a very short reply. 0.87. What is the ratio of the Taxes (in constant 2015 US$) of Brazil in 2007 to that in 2009?
Your answer should be compact. 0.85. What is the ratio of the Taxes (in constant 2015 US$) of Finland in 2007 to that in 2009?
Your answer should be compact. 1. What is the ratio of the Taxes (in constant 2015 US$) of Montenegro in 2007 to that in 2009?
Your answer should be compact. 1.06. What is the ratio of the Taxes (in constant 2015 US$) in Brazil in 2007 to that in 2010?
Keep it short and to the point. 0.62. What is the ratio of the Taxes (in constant 2015 US$) of Finland in 2007 to that in 2010?
Offer a terse response. 1.01. What is the ratio of the Taxes (in constant 2015 US$) of Montenegro in 2007 to that in 2010?
Offer a very short reply. 1.1. What is the ratio of the Taxes (in constant 2015 US$) in Serbia in 2007 to that in 2010?
Offer a terse response. 1.04. What is the ratio of the Taxes (in constant 2015 US$) in Brazil in 2008 to that in 2009?
Give a very brief answer. 1.09. What is the ratio of the Taxes (in constant 2015 US$) of Finland in 2008 to that in 2009?
Your response must be concise. 1.08. What is the ratio of the Taxes (in constant 2015 US$) in Montenegro in 2008 to that in 2009?
Your answer should be compact. 1.26. What is the ratio of the Taxes (in constant 2015 US$) of Serbia in 2008 to that in 2009?
Your response must be concise. 1.14. What is the ratio of the Taxes (in constant 2015 US$) in Brazil in 2008 to that in 2010?
Keep it short and to the point. 0.8. What is the ratio of the Taxes (in constant 2015 US$) of Finland in 2008 to that in 2010?
Keep it short and to the point. 1.1. What is the ratio of the Taxes (in constant 2015 US$) of Montenegro in 2008 to that in 2010?
Keep it short and to the point. 1.3. What is the ratio of the Taxes (in constant 2015 US$) in Serbia in 2008 to that in 2010?
Ensure brevity in your answer.  1.2. What is the ratio of the Taxes (in constant 2015 US$) in Brazil in 2009 to that in 2010?
Provide a short and direct response. 0.73. What is the ratio of the Taxes (in constant 2015 US$) in Finland in 2009 to that in 2010?
Give a very brief answer. 1.01. What is the ratio of the Taxes (in constant 2015 US$) of Montenegro in 2009 to that in 2010?
Give a very brief answer. 1.03. What is the ratio of the Taxes (in constant 2015 US$) of Serbia in 2009 to that in 2010?
Ensure brevity in your answer.  1.05. What is the difference between the highest and the second highest Taxes (in constant 2015 US$) in Brazil?
Give a very brief answer. 6.78e+1. What is the difference between the highest and the second highest Taxes (in constant 2015 US$) of Finland?
Make the answer very short. 2.66e+09. What is the difference between the highest and the second highest Taxes (in constant 2015 US$) of Montenegro?
Offer a very short reply. 1.40e+08. What is the difference between the highest and the second highest Taxes (in constant 2015 US$) of Serbia?
Keep it short and to the point. 9.33e+08. What is the difference between the highest and the lowest Taxes (in constant 2015 US$) of Brazil?
Give a very brief answer. 2.30e+11. What is the difference between the highest and the lowest Taxes (in constant 2015 US$) in Finland?
Offer a terse response. 9.67e+09. What is the difference between the highest and the lowest Taxes (in constant 2015 US$) in Montenegro?
Offer a very short reply. 5.84e+08. What is the difference between the highest and the lowest Taxes (in constant 2015 US$) of Serbia?
Give a very brief answer. 3.90e+09. 